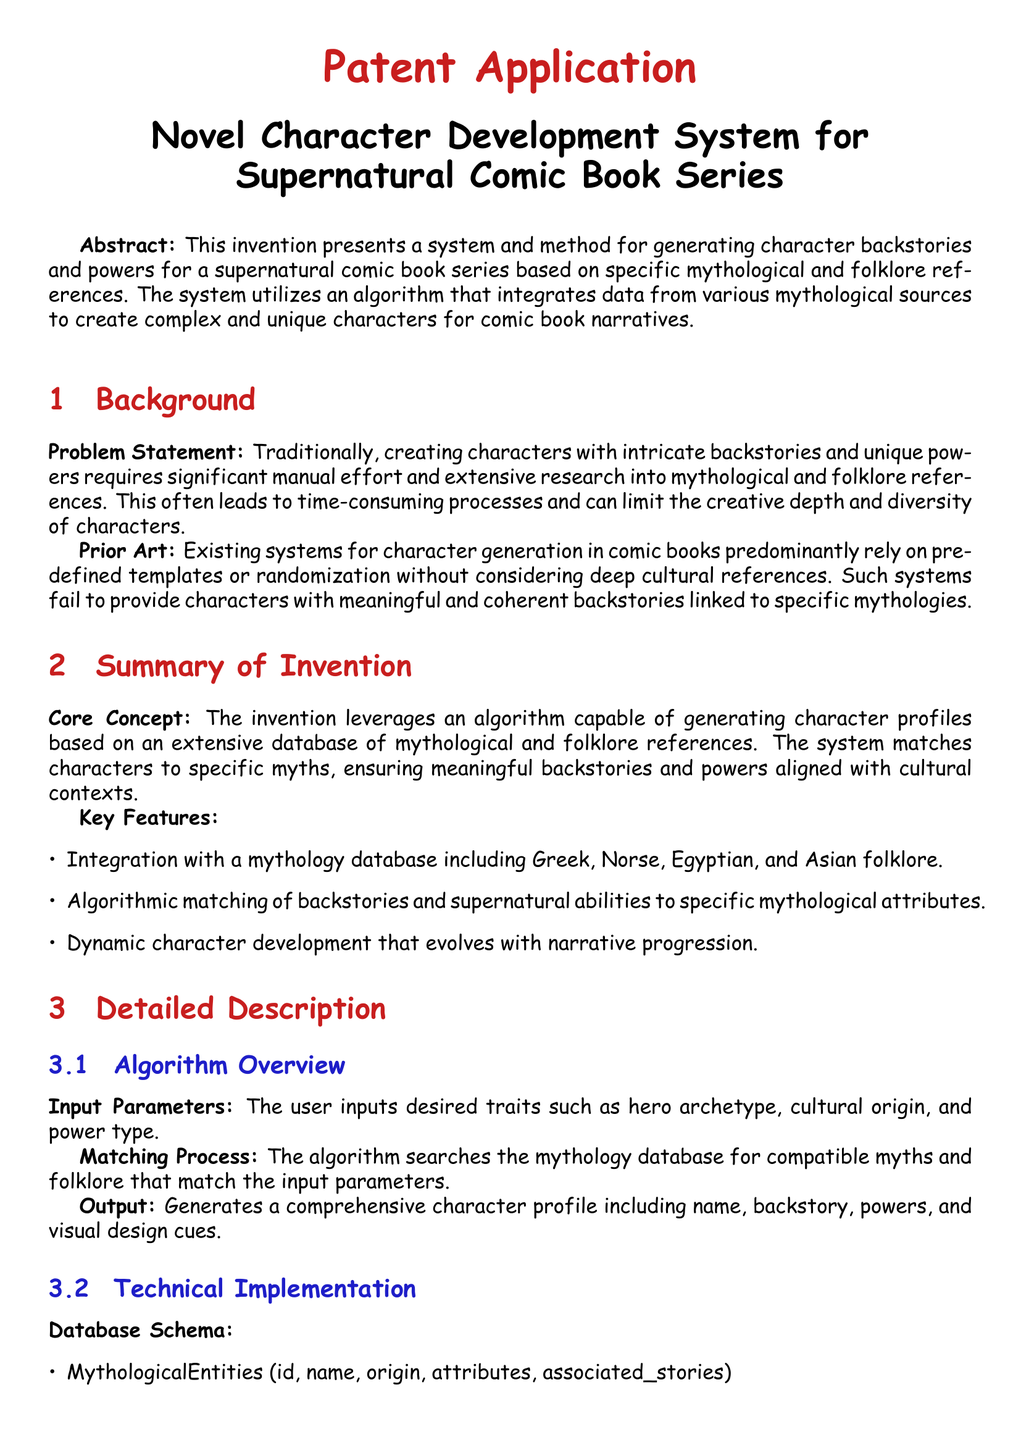what is the title of the patent application? The title of the patent application is stated at the beginning of the document.
Answer: Novel Character Development System for Supernatural Comic Book Series who is the inventor listed in the document? The inventor's name is presented in the document within the claims section.
Answer: John Doe which mythologies are included in the mythological database? The document explicitly mentions the mythologies included in the system's database.
Answer: Greek, Norse, Egyptian, and Asian folklore what type of process does the algorithm utilize for character generation? The type of process used by the algorithm is described in the summary of invention section.
Answer: Matching what is the first step in the algorithm pseudocode? The first step outlines the initial user inputs necessary for the algorithm's operation.
Answer: Receive user inputs for archetype, cultural origin, and power type how does the system evolve character profiles? The document mentions how character profiles adapt as narratives progress.
Answer: Dynamically what is the purpose of the Novel Character Development System? The purpose is found in the abstract, summarizing the invention's goals.
Answer: To generate character backstories and powers how many claims are presented in the claims section? The total number of claims is indicated by counting the items listed in that section of the document.
Answer: Three 